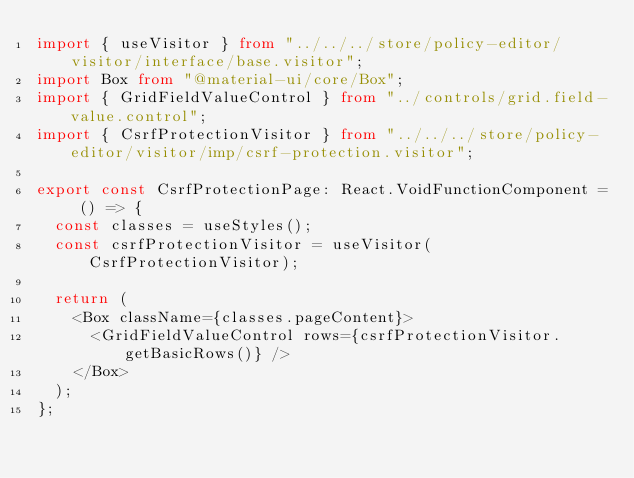<code> <loc_0><loc_0><loc_500><loc_500><_TypeScript_>import { useVisitor } from "../../../store/policy-editor/visitor/interface/base.visitor";
import Box from "@material-ui/core/Box";
import { GridFieldValueControl } from "../controls/grid.field-value.control";
import { CsrfProtectionVisitor } from "../../../store/policy-editor/visitor/imp/csrf-protection.visitor";

export const CsrfProtectionPage: React.VoidFunctionComponent = () => {
  const classes = useStyles();
  const csrfProtectionVisitor = useVisitor(CsrfProtectionVisitor);

  return (
    <Box className={classes.pageContent}>
      <GridFieldValueControl rows={csrfProtectionVisitor.getBasicRows()} />
    </Box>
  );
};
</code> 